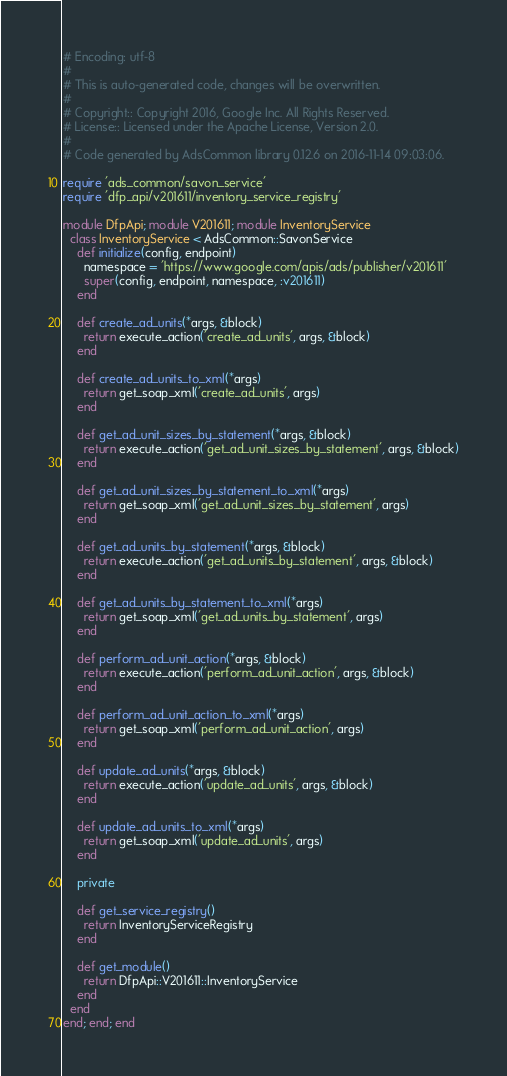<code> <loc_0><loc_0><loc_500><loc_500><_Ruby_># Encoding: utf-8
#
# This is auto-generated code, changes will be overwritten.
#
# Copyright:: Copyright 2016, Google Inc. All Rights Reserved.
# License:: Licensed under the Apache License, Version 2.0.
#
# Code generated by AdsCommon library 0.12.6 on 2016-11-14 09:03:06.

require 'ads_common/savon_service'
require 'dfp_api/v201611/inventory_service_registry'

module DfpApi; module V201611; module InventoryService
  class InventoryService < AdsCommon::SavonService
    def initialize(config, endpoint)
      namespace = 'https://www.google.com/apis/ads/publisher/v201611'
      super(config, endpoint, namespace, :v201611)
    end

    def create_ad_units(*args, &block)
      return execute_action('create_ad_units', args, &block)
    end

    def create_ad_units_to_xml(*args)
      return get_soap_xml('create_ad_units', args)
    end

    def get_ad_unit_sizes_by_statement(*args, &block)
      return execute_action('get_ad_unit_sizes_by_statement', args, &block)
    end

    def get_ad_unit_sizes_by_statement_to_xml(*args)
      return get_soap_xml('get_ad_unit_sizes_by_statement', args)
    end

    def get_ad_units_by_statement(*args, &block)
      return execute_action('get_ad_units_by_statement', args, &block)
    end

    def get_ad_units_by_statement_to_xml(*args)
      return get_soap_xml('get_ad_units_by_statement', args)
    end

    def perform_ad_unit_action(*args, &block)
      return execute_action('perform_ad_unit_action', args, &block)
    end

    def perform_ad_unit_action_to_xml(*args)
      return get_soap_xml('perform_ad_unit_action', args)
    end

    def update_ad_units(*args, &block)
      return execute_action('update_ad_units', args, &block)
    end

    def update_ad_units_to_xml(*args)
      return get_soap_xml('update_ad_units', args)
    end

    private

    def get_service_registry()
      return InventoryServiceRegistry
    end

    def get_module()
      return DfpApi::V201611::InventoryService
    end
  end
end; end; end
</code> 